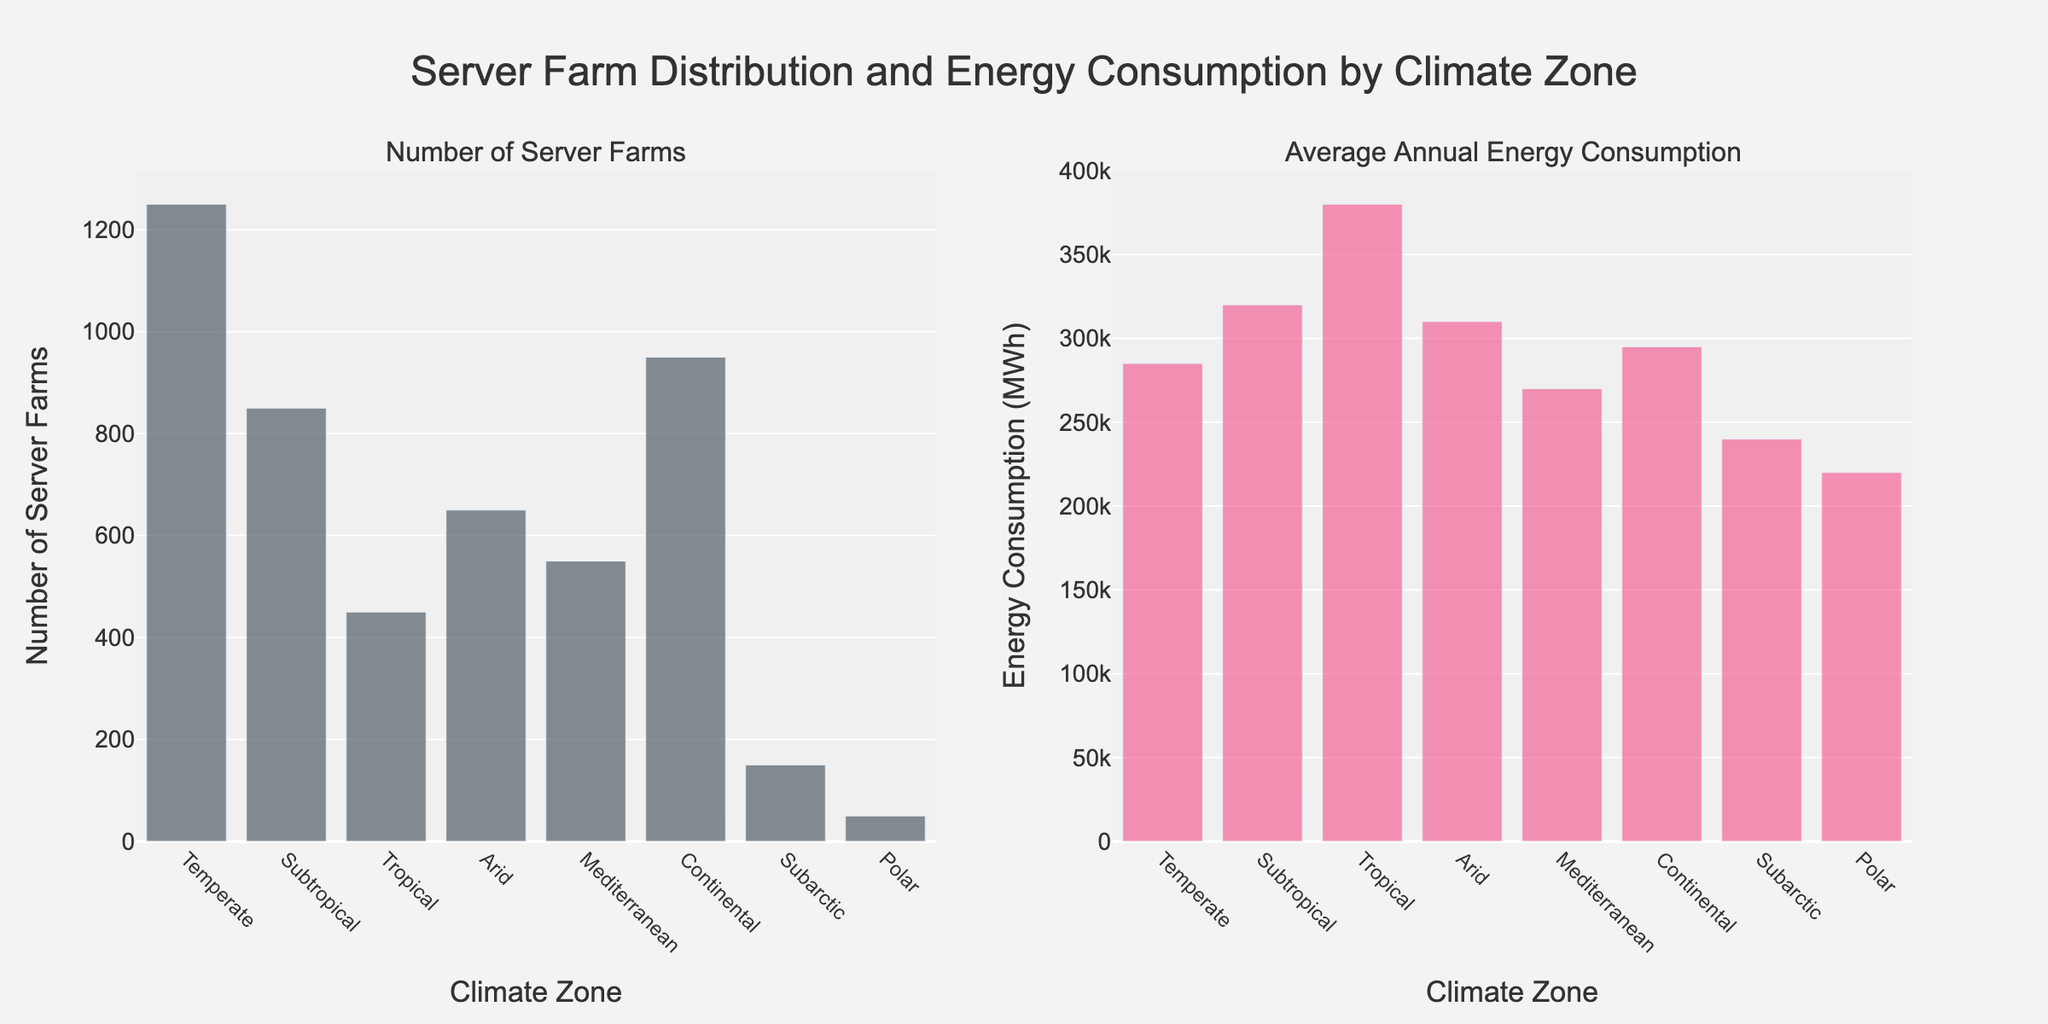Which climate zone has the lowest number of server farms? From the left subplot, observe the height of the bars representing each climate zone. The smallest bar corresponds to the Polar zone.
Answer: Polar What is the average annual energy consumption in the Subtropical zone? Refer to the right subplot and find the bar labeled "Subtropical". The height of this bar indicates the value of 320,000 MWh.
Answer: 320,000 MWh Which climate zone has the highest average annual energy consumption? Look at the right subplot and identify the tallest bar. This bar is labeled "Tropical".
Answer: Tropical How many more server farms are there in the Continental zone compared to the Mediterranean zone? From the left subplot, find the bars for Continental (950) and Mediterranean (550). Compute the difference: 950 - 550.
Answer: 400 Rank the climate zones by the number of server farms from highest to lowest. Examine the left subplot and arrange the labels based on bar heights: Temperate (1250), Continental (950), Subtropical (850), Arid (650), Mediterranean (550), Tropical (450), Subarctic (150), Polar (50).
Answer: Temperate, Continental, Subtropical, Arid, Mediterranean, Tropical, Subarctic, Polar Which climate zone has the smallest average annual energy consumption? In the right subplot, locate the shortest bar, which corresponds to the Polar zone.
Answer: Polar What is the total number of server farms across all climate zones? Sum the values from the left subplot (1250 + 850 + 450 + 650 + 550 + 950 + 150 + 50). The result is 4900.
Answer: 4900 What is the difference in average annual energy consumption between the Arid and Continental zones? In the right subplot, find the bars for Arid (310,000 MWh) and Continental (295,000 MWh). Compute the difference: 310,000 - 295,000.
Answer: 15,000 MWh Compare the appearance of the bars representing the Subarctic and Polar zones in terms of both the number of server farms and energy consumption. In the left subplot, the Subarctic has a higher bar compared to Polar, indicating more server farms (150 vs. 50). In the right subplot, Subarctic also has slightly higher average energy consumption (240,000 MWh vs. 220,000 MWh).
Answer: Subarctic has higher values in both aspects 